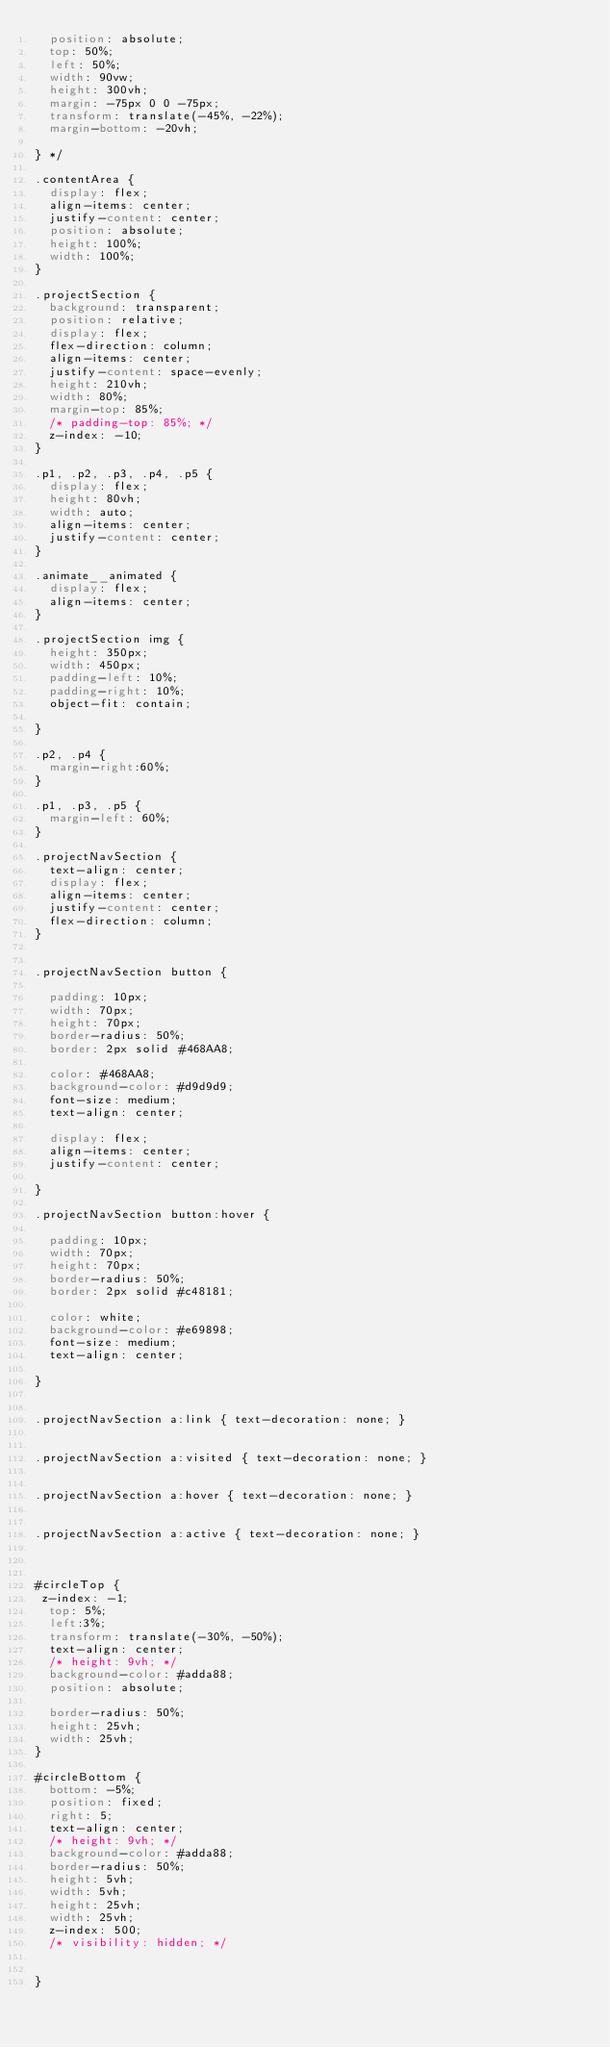<code> <loc_0><loc_0><loc_500><loc_500><_CSS_>  position: absolute;
  top: 50%;
  left: 50%;
  width: 90vw;
  height: 300vh;
  margin: -75px 0 0 -75px;
  transform: translate(-45%, -22%);
  margin-bottom: -20vh;

} */

.contentArea {
  display: flex;
  align-items: center;
  justify-content: center;
  position: absolute;
  height: 100%;
  width: 100%;
}

.projectSection {
  background: transparent;
  position: relative;
  display: flex;
  flex-direction: column;
  align-items: center;
  justify-content: space-evenly;
  height: 210vh;
  width: 80%;
  margin-top: 85%;
  /* padding-top: 85%; */
  z-index: -10;
}

.p1, .p2, .p3, .p4, .p5 {
  display: flex;
  height: 80vh;
  width: auto;
  align-items: center;
  justify-content: center;
}

.animate__animated {
  display: flex;
  align-items: center;
}

.projectSection img {
  height: 350px;
  width: 450px;
  padding-left: 10%;
  padding-right: 10%;
  object-fit: contain;

}

.p2, .p4 {
  margin-right:60%;
}

.p1, .p3, .p5 {
  margin-left: 60%;
}

.projectNavSection {
  text-align: center;
  display: flex;
  align-items: center;
  justify-content: center;
  flex-direction: column;
}


.projectNavSection button {

  padding: 10px;
  width: 70px;
  height: 70px;
  border-radius: 50%;
  border: 2px solid #468AA8;

  color: #468AA8;
  background-color: #d9d9d9;
  font-size: medium;
  text-align: center;

  display: flex;
  align-items: center;
  justify-content: center;

}

.projectNavSection button:hover {

  padding: 10px;
  width: 70px;
  height: 70px;
  border-radius: 50%;
  border: 2px solid #c48181;

  color: white;
  background-color: #e69898;
  font-size: medium;
  text-align: center;

}


.projectNavSection a:link { text-decoration: none; }


.projectNavSection a:visited { text-decoration: none; }


.projectNavSection a:hover { text-decoration: none; }


.projectNavSection a:active { text-decoration: none; }



#circleTop {
 z-index: -1;
  top: 5%;
  left:3%;
  transform: translate(-30%, -50%);
  text-align: center;
  /* height: 9vh; */
  background-color: #adda88;
  position: absolute;

  border-radius: 50%;
  height: 25vh;
  width: 25vh;
}

#circleBottom {
  bottom: -5%;
  position: fixed;
  right: 5;
  text-align: center;
  /* height: 9vh; */
  background-color: #adda88;
  border-radius: 50%;
  height: 5vh;
  width: 5vh;
  height: 25vh;
  width: 25vh;
  z-index: 500;
  /* visibility: hidden; */


}

</code> 